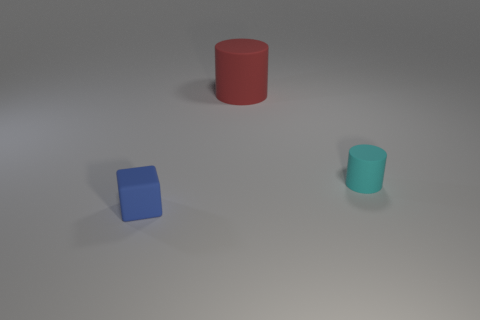How many other things are there of the same size as the blue matte cube?
Your answer should be very brief. 1. How many small objects are either cyan objects or green metallic things?
Keep it short and to the point. 1. Are there more things that are right of the small blue object than large red cylinders that are left of the big matte object?
Provide a short and direct response. Yes. Are there more tiny objects behind the blue rubber cube than tiny brown metallic spheres?
Your answer should be compact. Yes. Does the blue block have the same size as the red rubber cylinder?
Offer a terse response. No. There is a tiny cyan object that is the same shape as the red thing; what material is it?
Provide a short and direct response. Rubber. Are there any other things that have the same material as the cube?
Offer a terse response. Yes. What number of gray objects are either large rubber objects or tiny rubber cylinders?
Ensure brevity in your answer.  0. There is a small thing on the right side of the big cylinder; what is it made of?
Provide a succinct answer. Rubber. Is the number of cylinders greater than the number of large green rubber cylinders?
Your answer should be very brief. Yes. 